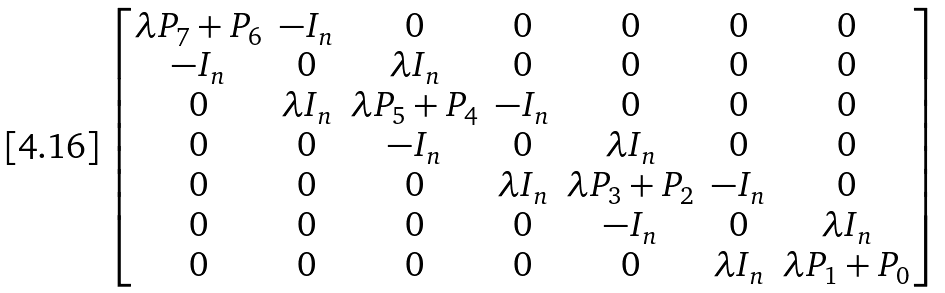Convert formula to latex. <formula><loc_0><loc_0><loc_500><loc_500>\begin{bmatrix} \lambda P _ { 7 } + P _ { 6 } & - I _ { n } & 0 & 0 & 0 & 0 & 0 \\ - I _ { n } & 0 & \lambda I _ { n } & 0 & 0 & 0 & 0 \\ 0 & \lambda I _ { n } & \lambda P _ { 5 } + P _ { 4 } & - I _ { n } & 0 & 0 & 0 \\ 0 & 0 & - I _ { n } & 0 & \lambda I _ { n } & 0 & 0 \\ 0 & 0 & 0 & \lambda I _ { n } & \lambda P _ { 3 } + P _ { 2 } & - I _ { n } & 0 \\ 0 & 0 & 0 & 0 & - I _ { n } & 0 & \lambda I _ { n } \\ 0 & 0 & 0 & 0 & 0 & \lambda I _ { n } & \lambda P _ { 1 } + P _ { 0 } \end{bmatrix}</formula> 